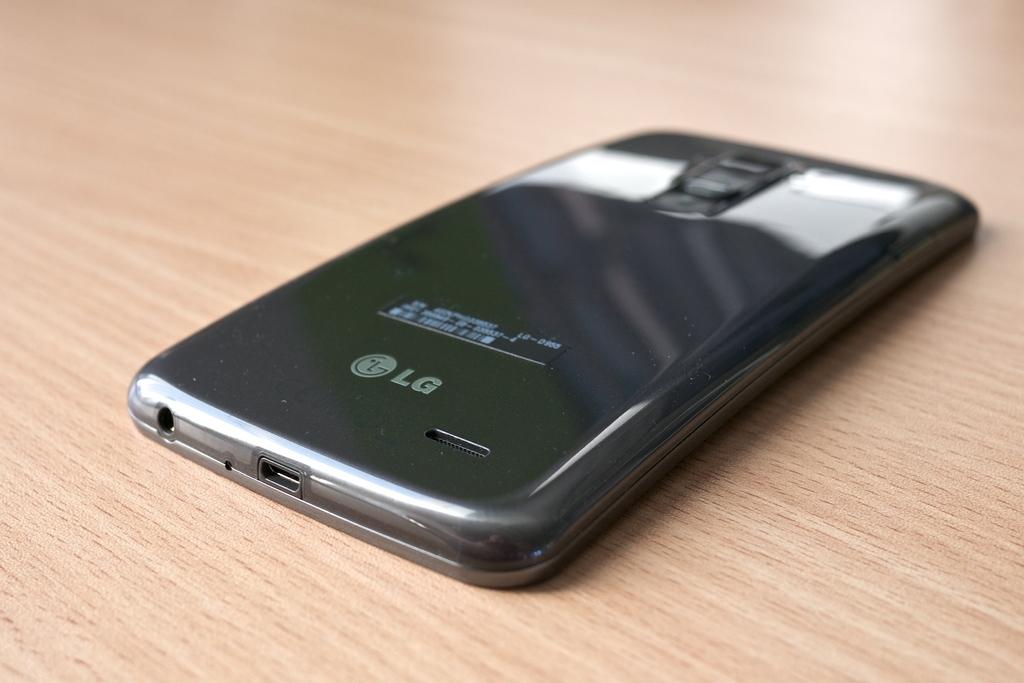What electronic device is visible in the image? There is a mobile phone in the image. Where is the mobile phone located? The mobile phone is present on a table. What type of wine is being served in the image? There is no wine present in the image; it only features a mobile phone on a table. Is there a gate visible in the image? There is no gate present in the image; it only features a mobile phone on a table. 